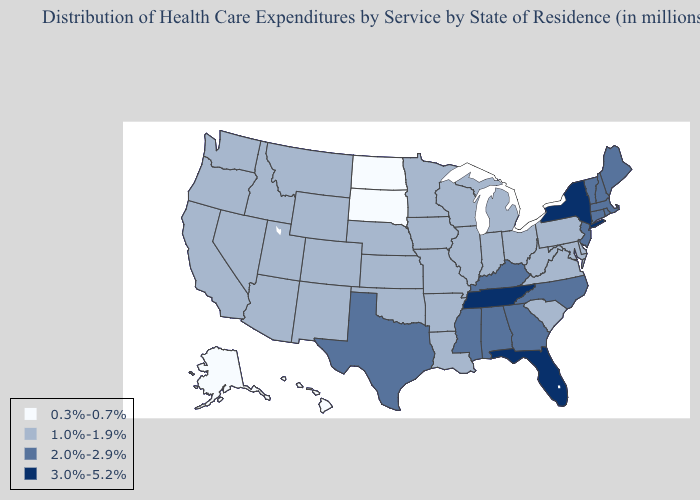What is the value of Michigan?
Give a very brief answer. 1.0%-1.9%. Name the states that have a value in the range 3.0%-5.2%?
Be succinct. Florida, New York, Tennessee. Does Colorado have a lower value than North Carolina?
Short answer required. Yes. Does the map have missing data?
Keep it brief. No. Does New Mexico have the lowest value in the USA?
Short answer required. No. What is the value of Arkansas?
Answer briefly. 1.0%-1.9%. What is the highest value in the USA?
Give a very brief answer. 3.0%-5.2%. What is the value of Rhode Island?
Give a very brief answer. 2.0%-2.9%. Does Vermont have a lower value than North Carolina?
Concise answer only. No. What is the lowest value in states that border Kansas?
Write a very short answer. 1.0%-1.9%. Does Nebraska have a lower value than Massachusetts?
Short answer required. Yes. What is the value of Georgia?
Answer briefly. 2.0%-2.9%. What is the value of Wisconsin?
Be succinct. 1.0%-1.9%. What is the value of Indiana?
Concise answer only. 1.0%-1.9%. Which states have the lowest value in the MidWest?
Short answer required. North Dakota, South Dakota. 